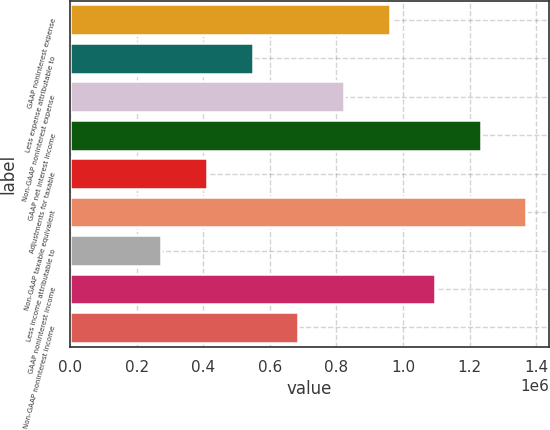Convert chart to OTSL. <chart><loc_0><loc_0><loc_500><loc_500><bar_chart><fcel>GAAP noninterest expense<fcel>Less expense attributable to<fcel>Non-GAAP noninterest expense<fcel>GAAP net interest income<fcel>Adjustments for taxable<fcel>Non-GAAP taxable equivalent<fcel>Less income attributable to<fcel>GAAP noninterest income<fcel>Non-GAAP noninterest income<nl><fcel>959399<fcel>548247<fcel>822348<fcel>1.2335e+06<fcel>411197<fcel>1.37055e+06<fcel>274146<fcel>1.09645e+06<fcel>685298<nl></chart> 